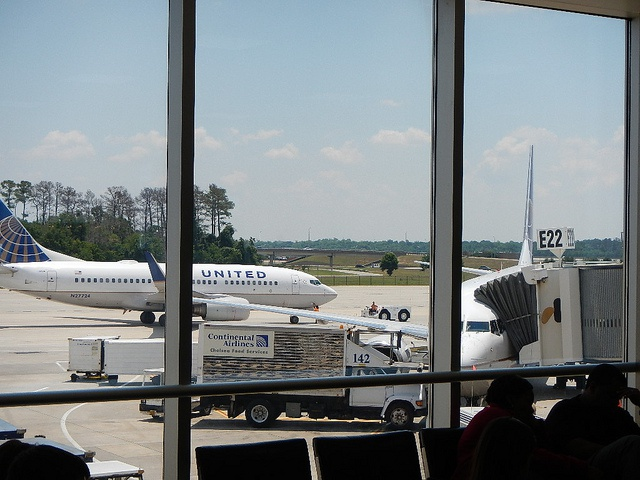Describe the objects in this image and their specific colors. I can see truck in darkgray, black, and gray tones, airplane in darkgray, lightgray, gray, and navy tones, airplane in darkgray, lightgray, and gray tones, people in darkgray and black tones, and chair in darkgray, black, navy, and gray tones in this image. 